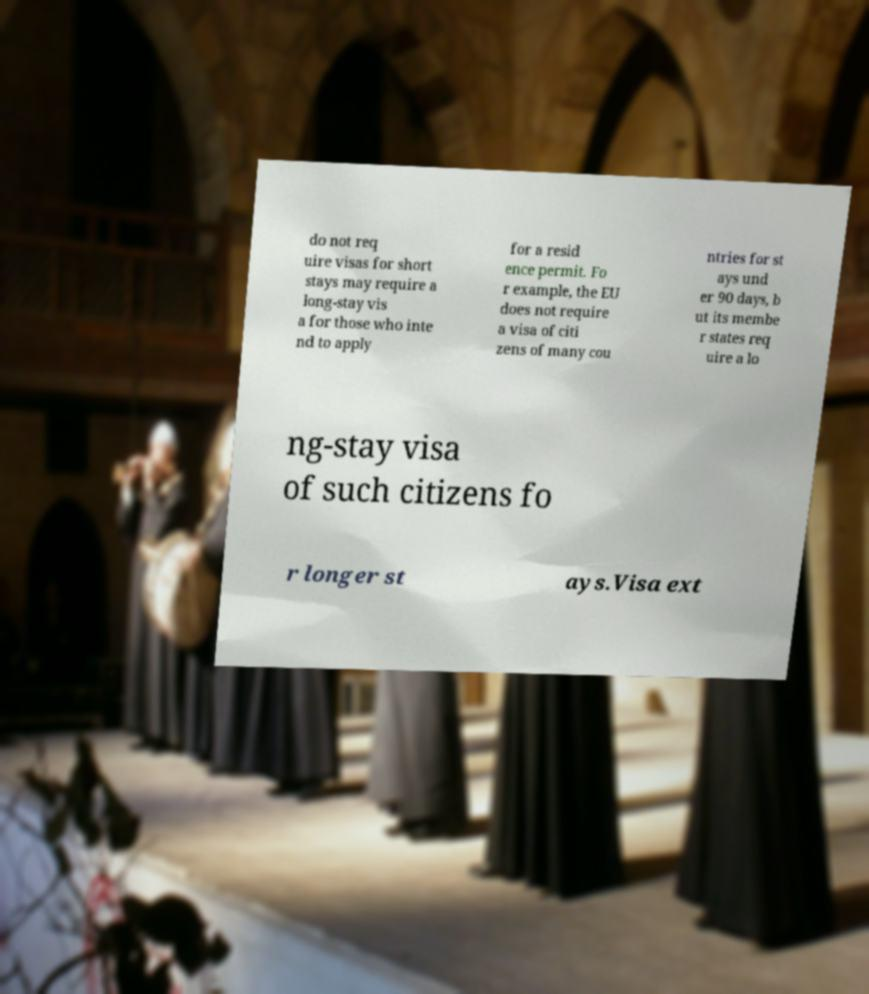For documentation purposes, I need the text within this image transcribed. Could you provide that? do not req uire visas for short stays may require a long-stay vis a for those who inte nd to apply for a resid ence permit. Fo r example, the EU does not require a visa of citi zens of many cou ntries for st ays und er 90 days, b ut its membe r states req uire a lo ng-stay visa of such citizens fo r longer st ays.Visa ext 